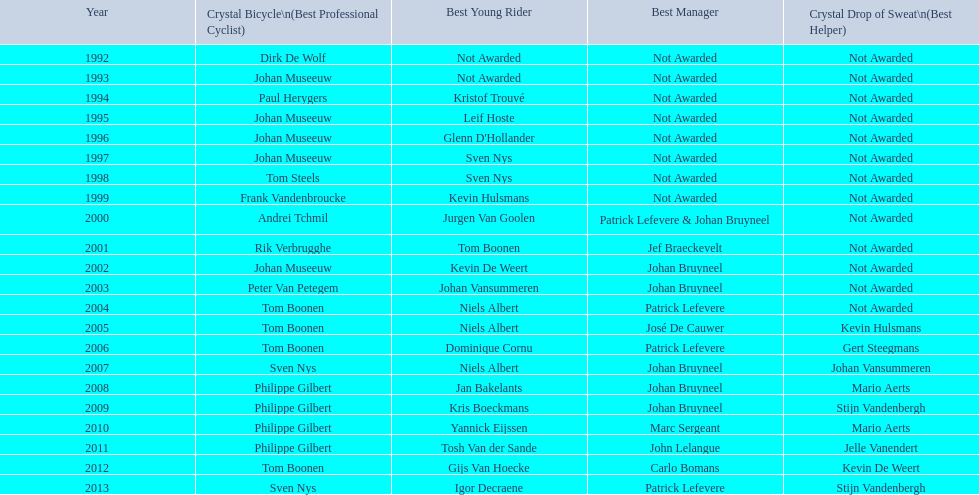What is the average number of times johan museeuw starred? 5. 